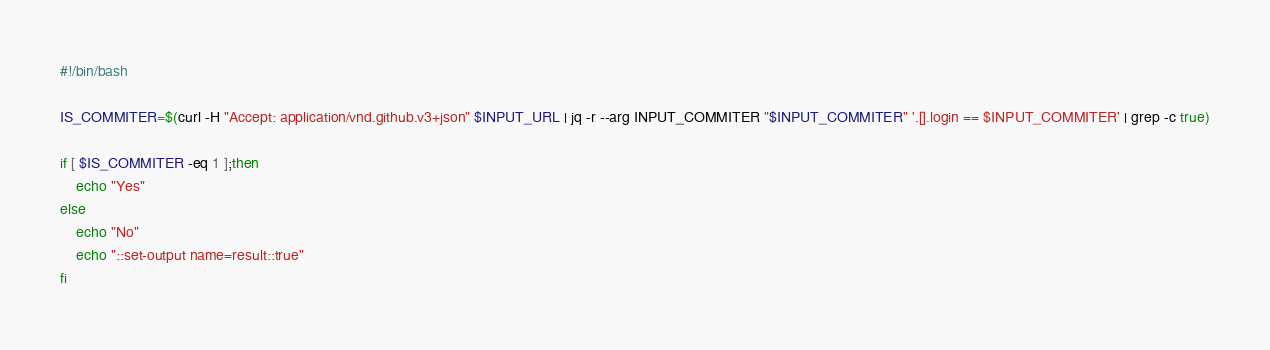Convert code to text. <code><loc_0><loc_0><loc_500><loc_500><_Bash_>#!/bin/bash

IS_COMMITER=$(curl -H "Accept: application/vnd.github.v3+json" $INPUT_URL | jq -r --arg INPUT_COMMITER "$INPUT_COMMITER" '.[].login == $INPUT_COMMITER' | grep -c true)

if [ $IS_COMMITER -eq 1 ];then
    echo "Yes"
else
    echo "No"
    echo "::set-output name=result::true"
fi
</code> 